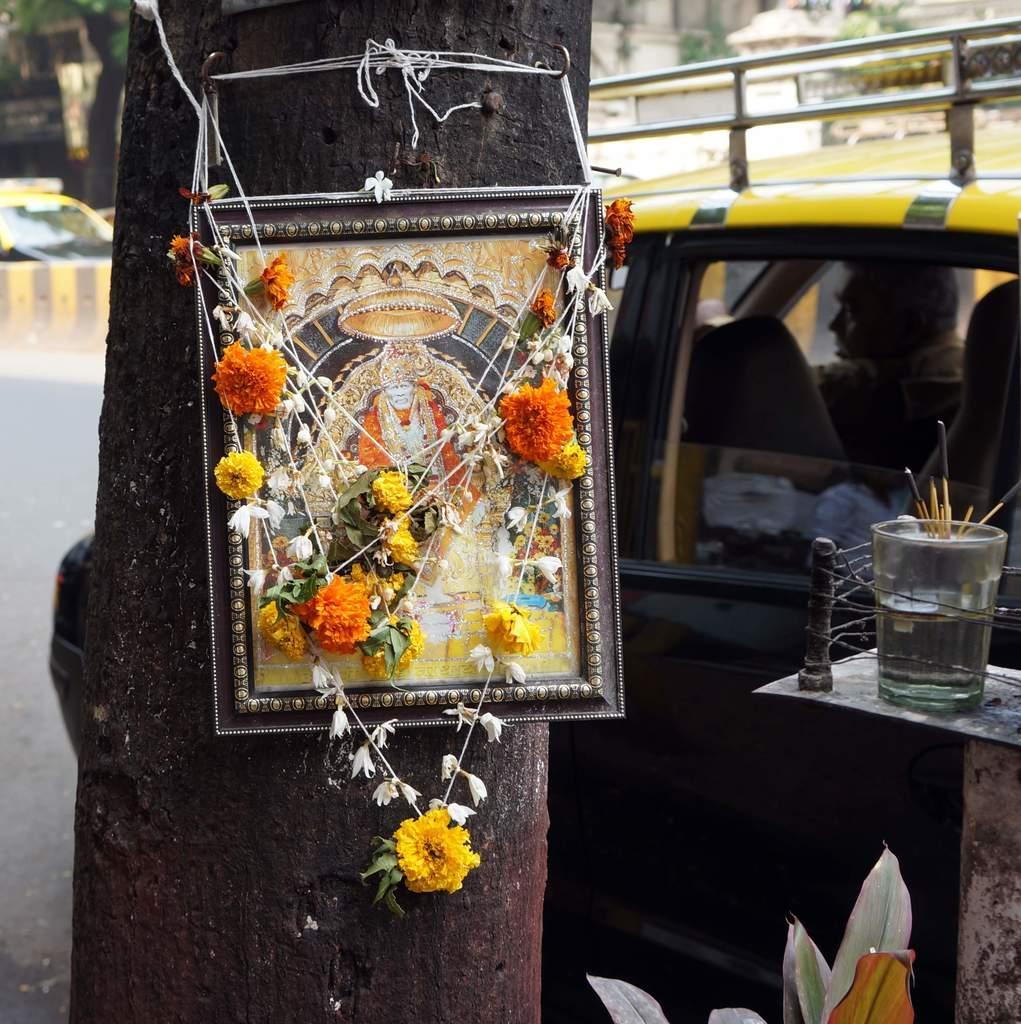In one or two sentences, can you explain what this image depicts? There is a tree trunk. On the tree trunk there is a photo frame of a god. On that there are garlands with flowers. Near to that there is a plant and stand. On the stand there is a glass with sandal sticks. In the back there is a car. Inside the car there is a man. 